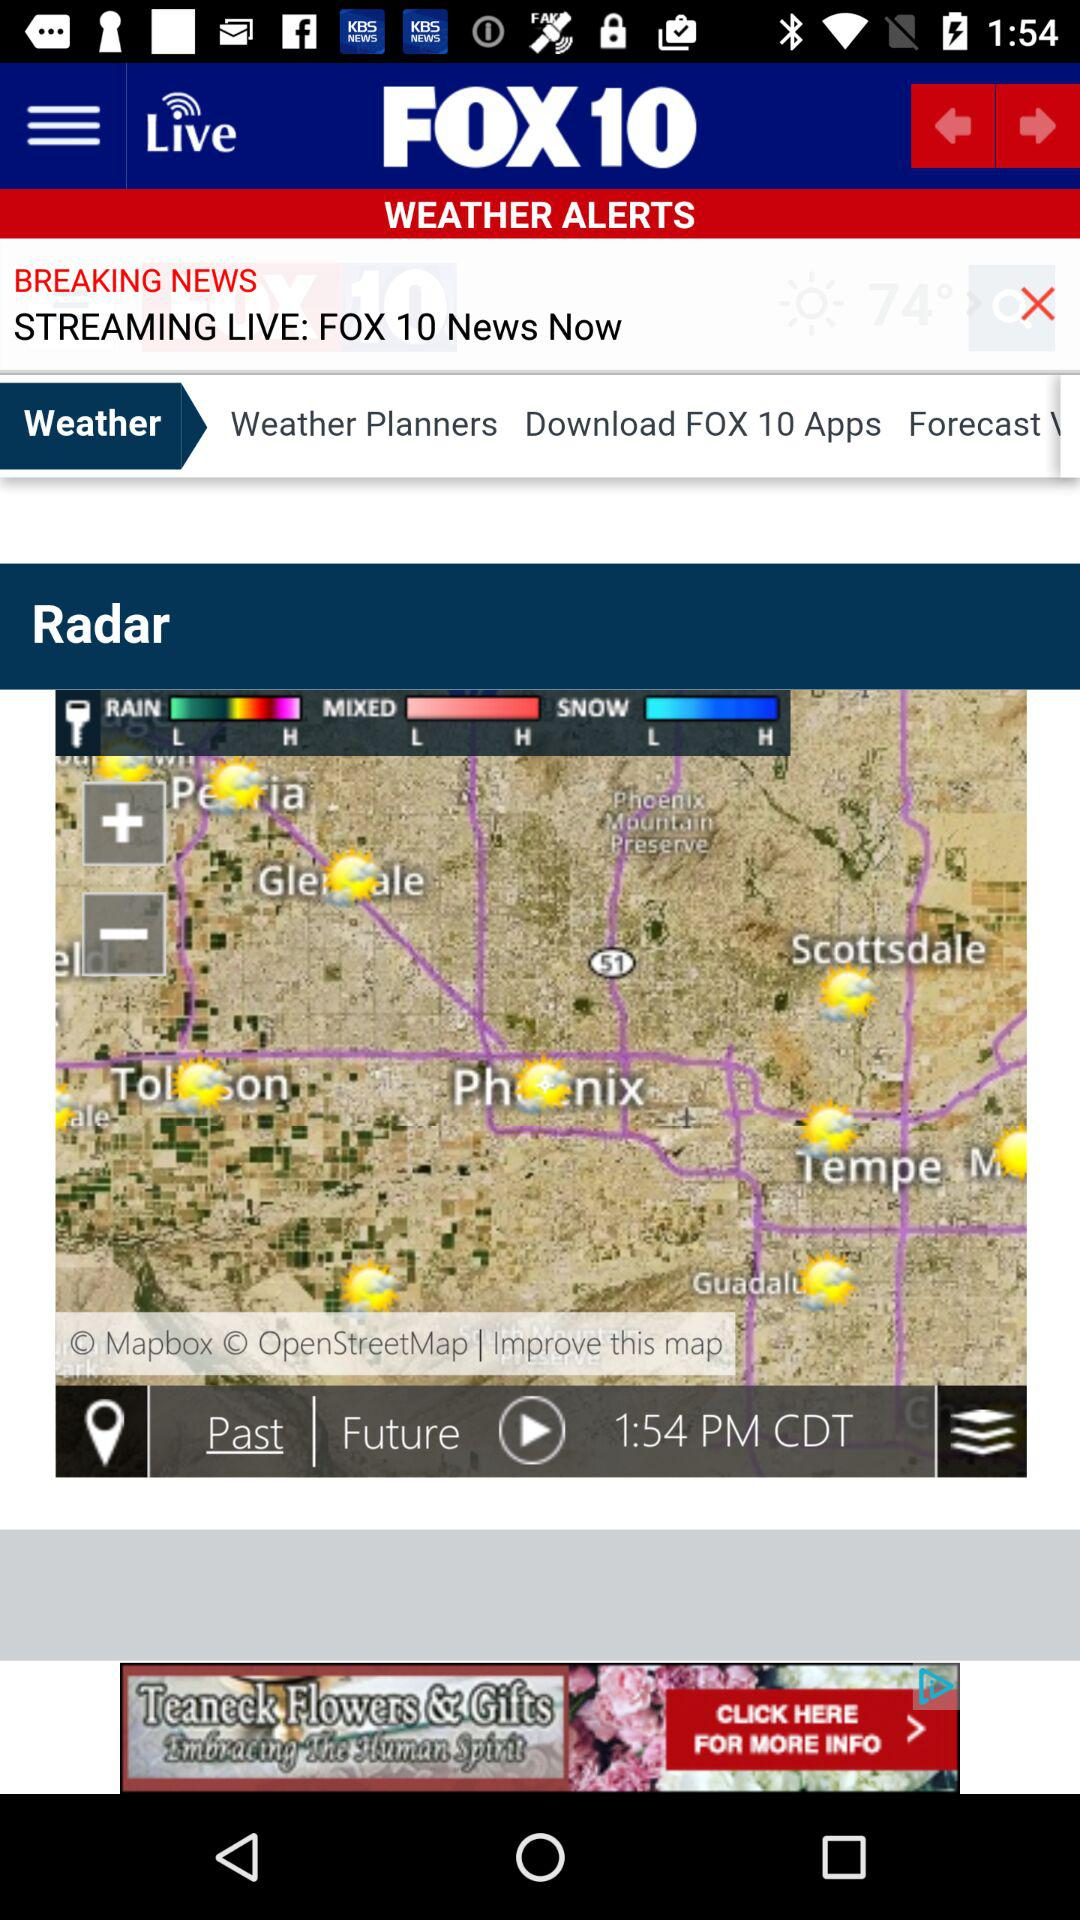What is the name of the application? The name of the application is "FOX 10". 